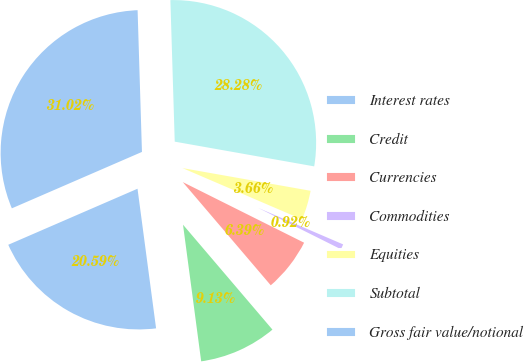Convert chart to OTSL. <chart><loc_0><loc_0><loc_500><loc_500><pie_chart><fcel>Interest rates<fcel>Credit<fcel>Currencies<fcel>Commodities<fcel>Equities<fcel>Subtotal<fcel>Gross fair value/notional<nl><fcel>20.59%<fcel>9.13%<fcel>6.39%<fcel>0.92%<fcel>3.66%<fcel>28.28%<fcel>31.02%<nl></chart> 